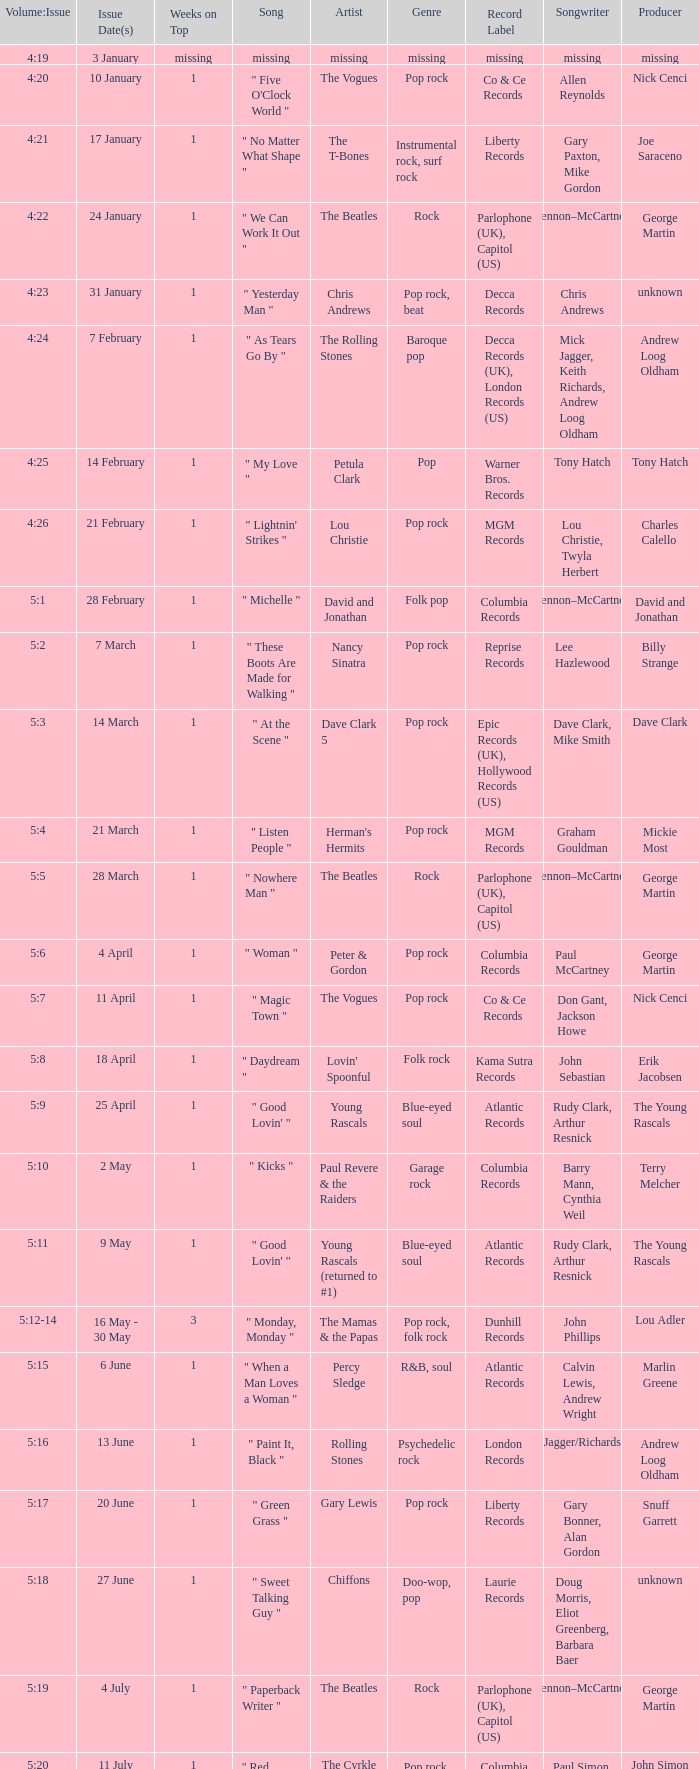An artist of the Beatles with an issue date(s) of 19 September has what as the listed weeks on top? 1.0. 